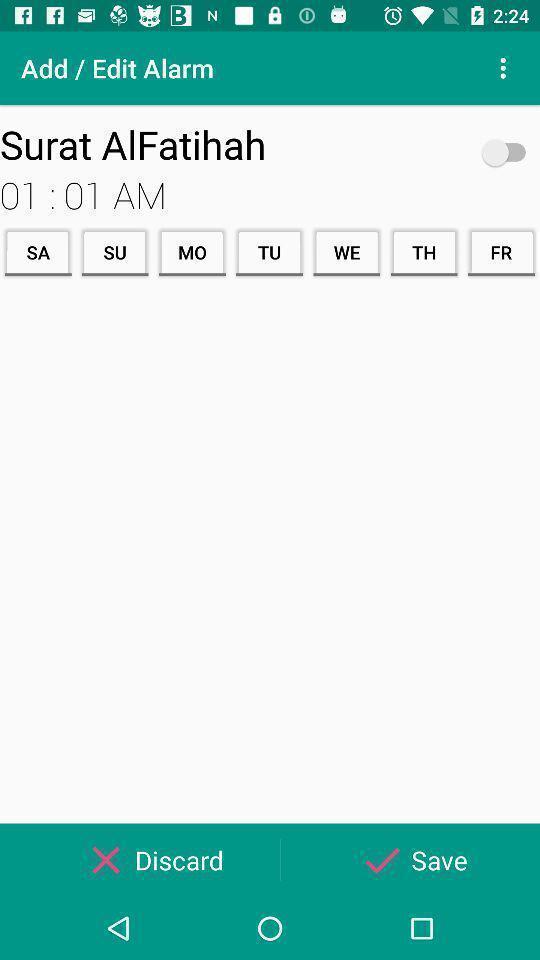Summarize the main components in this picture. Screen showing to edit an alarm. 